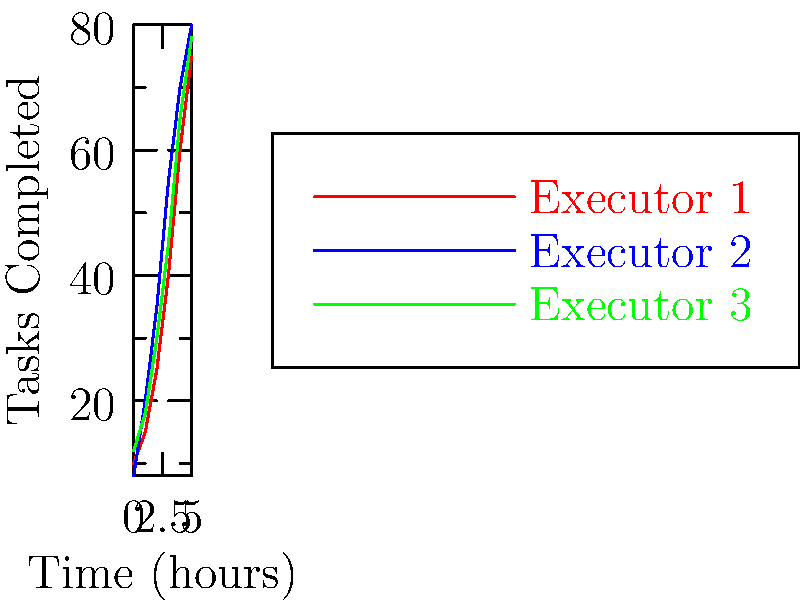Given the performance metrics of three Spark executors over time, calculate the area between the curves of Executor 1 and Executor 2 from t=1 to t=4 hours. What does this area represent in terms of Spark performance? To solve this problem, we need to follow these steps:

1. Identify the curves for Executor 1 and Executor 2.
2. Calculate the area under each curve from t=1 to t=4.
3. Subtract the smaller area from the larger area.

Step 1: Identify the curves
- Executor 1: red curve
- Executor 2: blue curve

Step 2: Calculate areas under curves
We can use the trapezoidal rule to approximate the area under each curve.

For Executor 1:
$A_1 = \frac{1}{2}[(15+25)+(25+40)+(40+60)] = 102.5$

For Executor 2:
$A_2 = \frac{1}{2}[(20+35)+(35+55)+(55+70)] = 135$

Step 3: Subtract areas
Area between curves = $A_2 - A_1 = 135 - 102.5 = 32.5$

This area represents the difference in cumulative tasks completed between Executor 2 and Executor 1 over the time period from 1 to 4 hours. A positive value indicates that Executor 2 completed more tasks overall during this time frame.

In terms of Spark performance, this area signifies the relative efficiency of Executor 2 compared to Executor 1. The larger area suggests that Executor 2 was more productive in processing tasks during the given time period, which could be due to factors such as better resource allocation, optimized code execution, or more efficient data processing strategies.
Answer: 32.5 task-hours (Executor 2 outperformed Executor 1) 